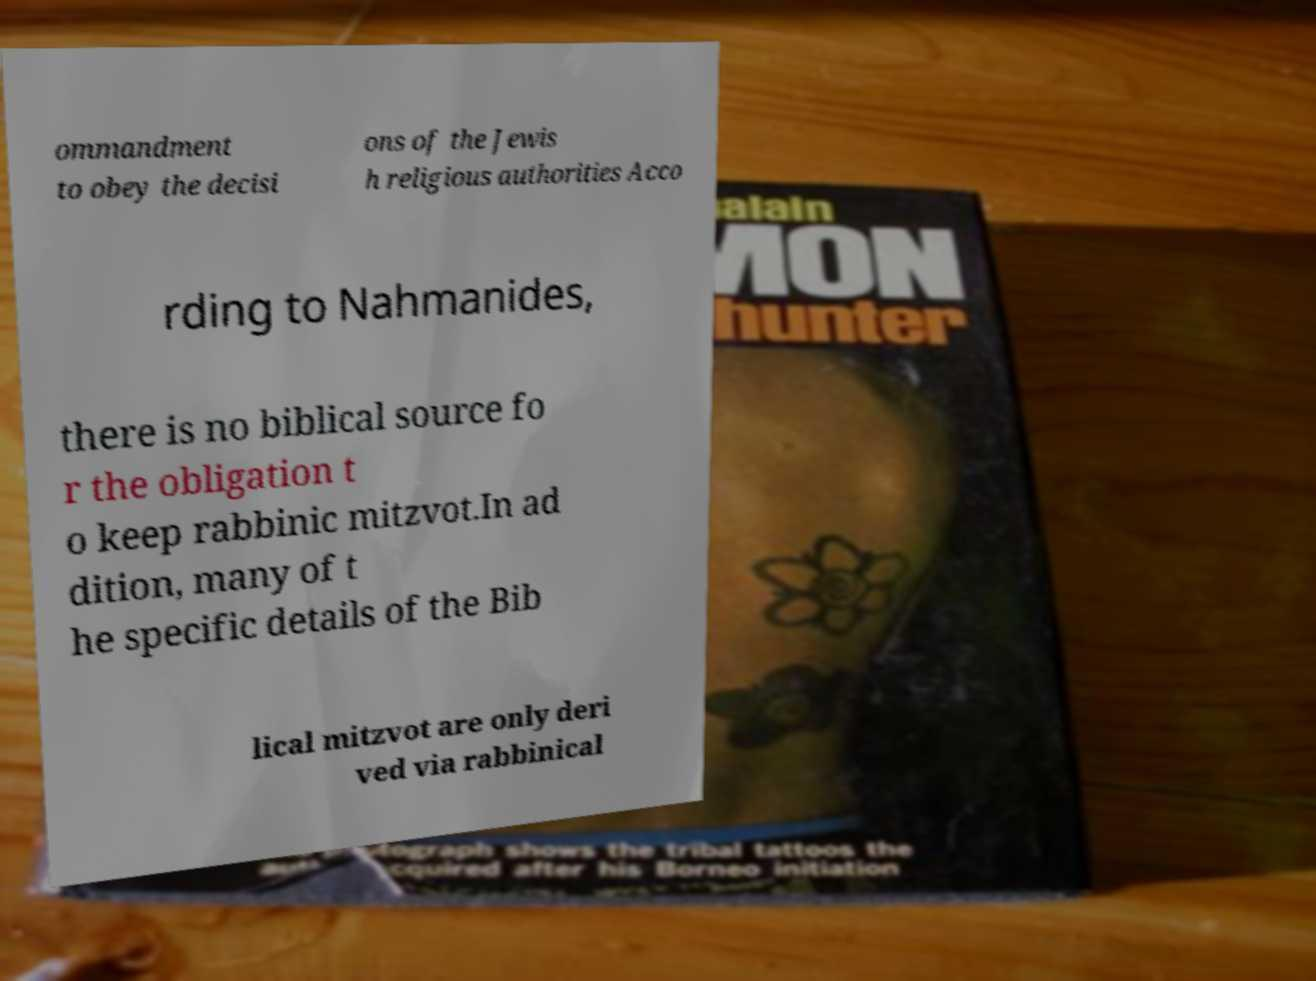What messages or text are displayed in this image? I need them in a readable, typed format. ommandment to obey the decisi ons of the Jewis h religious authorities Acco rding to Nahmanides, there is no biblical source fo r the obligation t o keep rabbinic mitzvot.In ad dition, many of t he specific details of the Bib lical mitzvot are only deri ved via rabbinical 